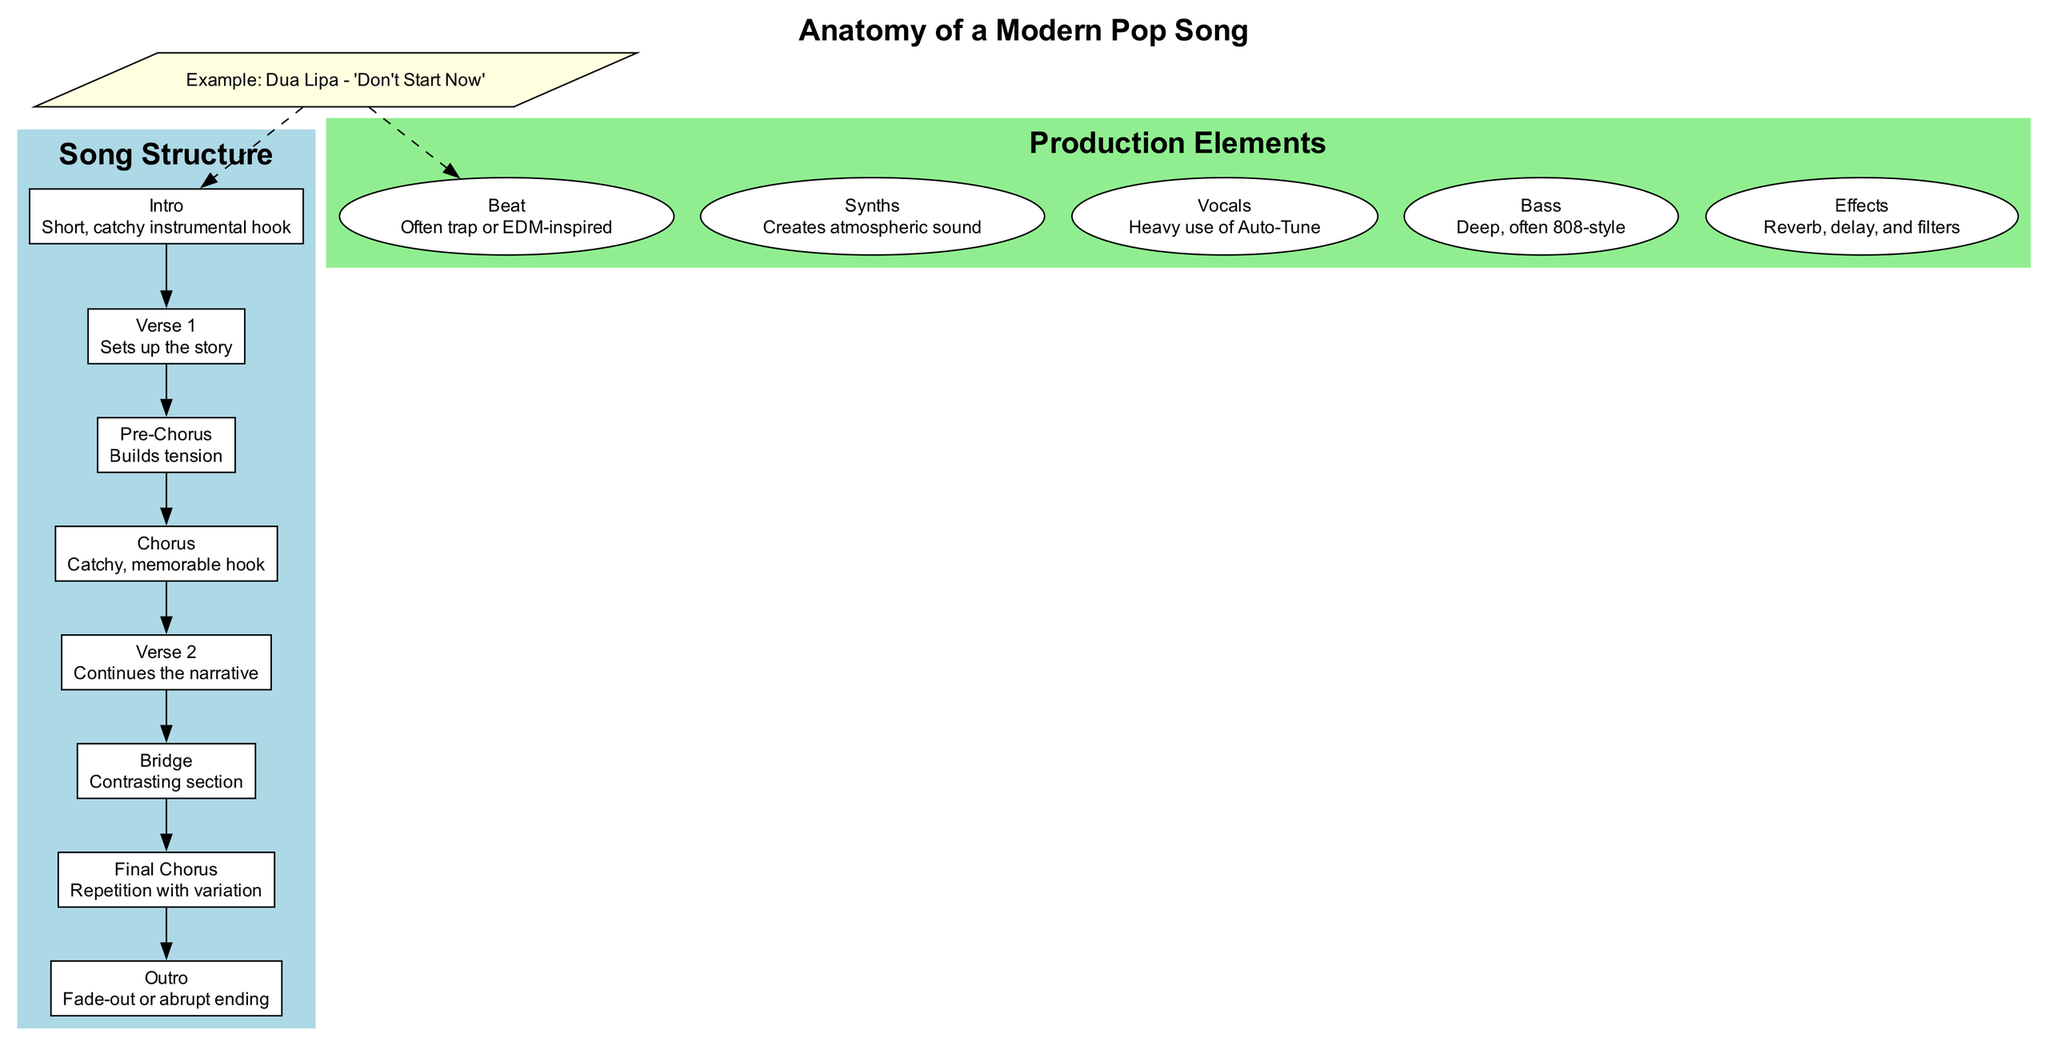What's the first section of a modern pop song? The first section listed in the diagram is "Intro," described as a "Short, catchy instrumental hook." This is the initial part of the song structure.
Answer: Intro How many main sections are in the song structure? By counting the main sections in the diagram, we find there are eight distinct sections from "Intro" to "Outro." This includes all individual parts listed.
Answer: 8 What is used to create an atmospheric sound in production elements? The diagram specifies "Synths" as the production element that is responsible for creating an atmospheric sound. This is directly stated in the description of that element.
Answer: Synths What section builds tension before the chorus? Looking at the song structure in the diagram, the section immediately preceding the "Chorus" is the "Pre-Chorus," which is described as "Builds tension." This indicates its role in the song's progression.
Answer: Pre-Chorus Which section follows "Verse 1"? In the order of sections as described in the diagram, the section that directly follows "Verse 1" is the "Pre-Chorus." This follows the sequential structure of the song.
Answer: Pre-Chorus What type of beat is commonly used in modern pop songs? The diagram indicates that the "Beat" used in modern pop music is often "trap or EDM-inspired." This is stated in the description of the production element labeled "Beat."
Answer: trap or EDM-inspired What is the purpose of the "Bridge" in the song structure? The diagram describes the "Bridge" as a "Contrasting section." This implies its role is to provide a difference in the song after repeating other sections, adding variety.
Answer: Contrasting section What is the final section of a modern pop song? The last section listed in the diagram is "Outro," which is described as having a "Fade-out or abrupt ending." This indicates it is the closing part of the song.
Answer: Outro Which production element involves heavy use of Auto-Tune? According to the diagram, the "Vocals" are associated with "Heavy use of Auto-Tune" in the description of that production element. This highlights the modern approach to vocal production in pop music.
Answer: Vocals 